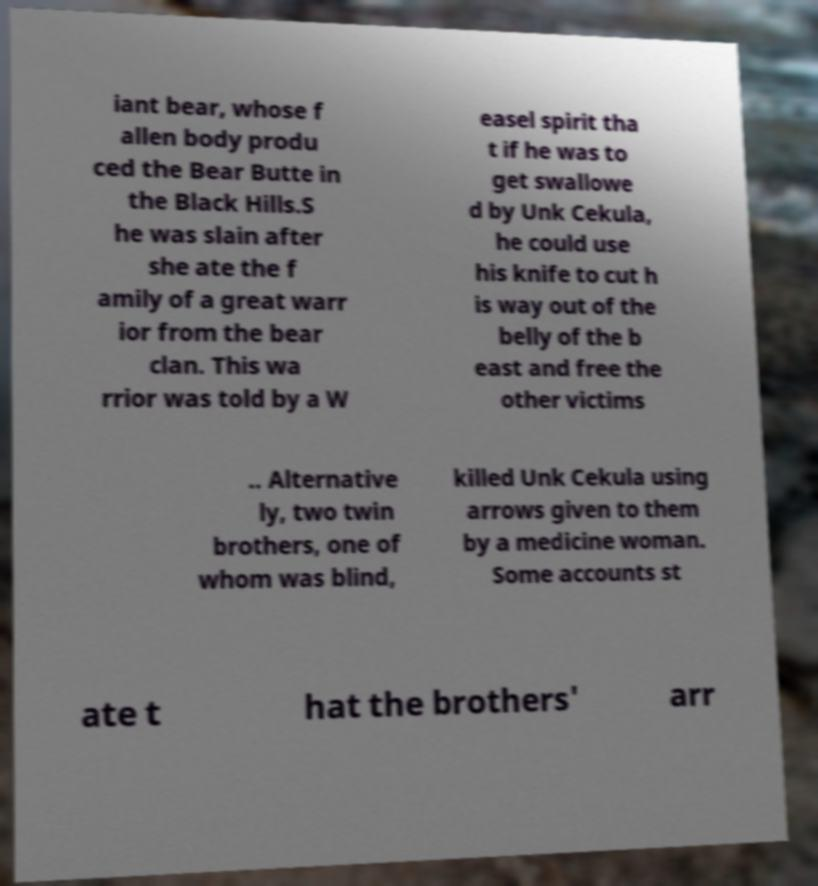There's text embedded in this image that I need extracted. Can you transcribe it verbatim? iant bear, whose f allen body produ ced the Bear Butte in the Black Hills.S he was slain after she ate the f amily of a great warr ior from the bear clan. This wa rrior was told by a W easel spirit tha t if he was to get swallowe d by Unk Cekula, he could use his knife to cut h is way out of the belly of the b east and free the other victims .. Alternative ly, two twin brothers, one of whom was blind, killed Unk Cekula using arrows given to them by a medicine woman. Some accounts st ate t hat the brothers' arr 